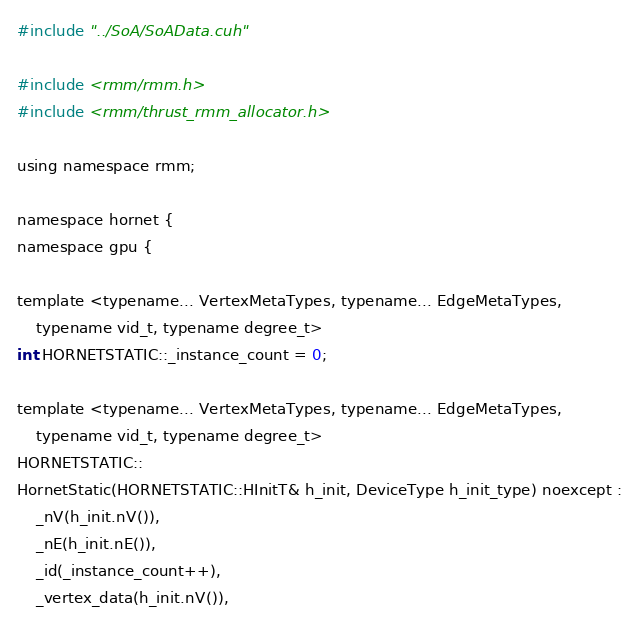<code> <loc_0><loc_0><loc_500><loc_500><_Cuda_>#include "../SoA/SoAData.cuh"

#include <rmm/rmm.h>
#include <rmm/thrust_rmm_allocator.h>

using namespace rmm;

namespace hornet {
namespace gpu {

template <typename... VertexMetaTypes, typename... EdgeMetaTypes,
    typename vid_t, typename degree_t>
int HORNETSTATIC::_instance_count = 0;

template <typename... VertexMetaTypes, typename... EdgeMetaTypes,
    typename vid_t, typename degree_t>
HORNETSTATIC::
HornetStatic(HORNETSTATIC::HInitT& h_init, DeviceType h_init_type) noexcept :
    _nV(h_init.nV()),
    _nE(h_init.nE()),
    _id(_instance_count++),
    _vertex_data(h_init.nV()),</code> 